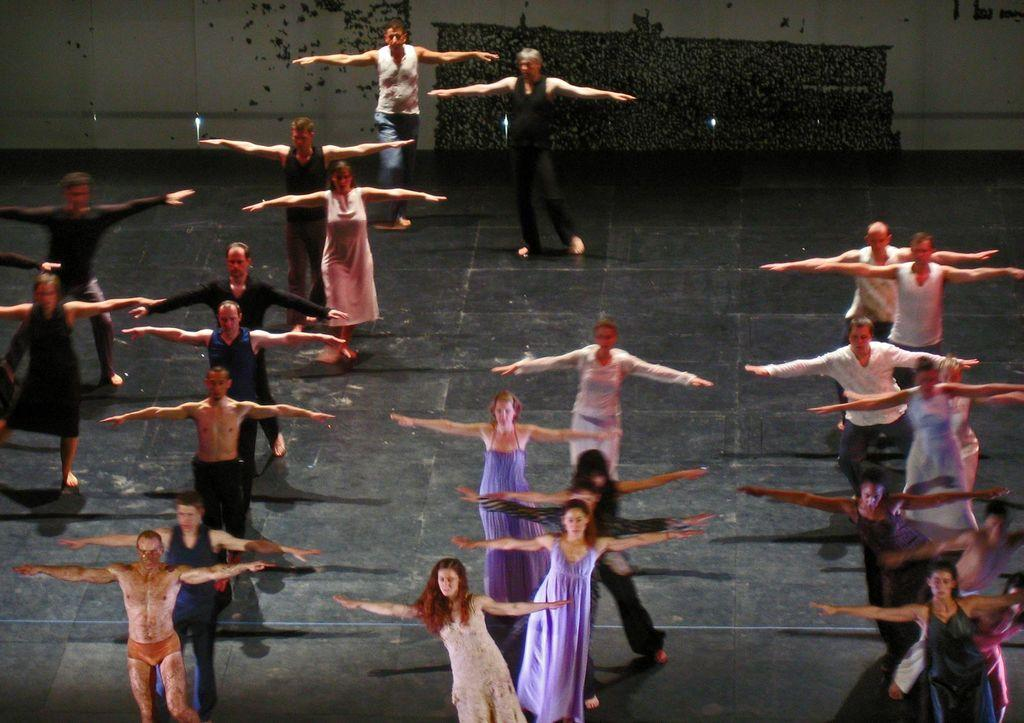Where was the image taken? The image was taken inside a hall. What are the people in the image doing? The people appear to be dancing. What can be seen in the background of the image? There is a wall visible in the background of the image, along with other objects. How many tails can be seen on the people dancing in the image? There are no tails visible on the people dancing in the image, as humans do not have tails. 